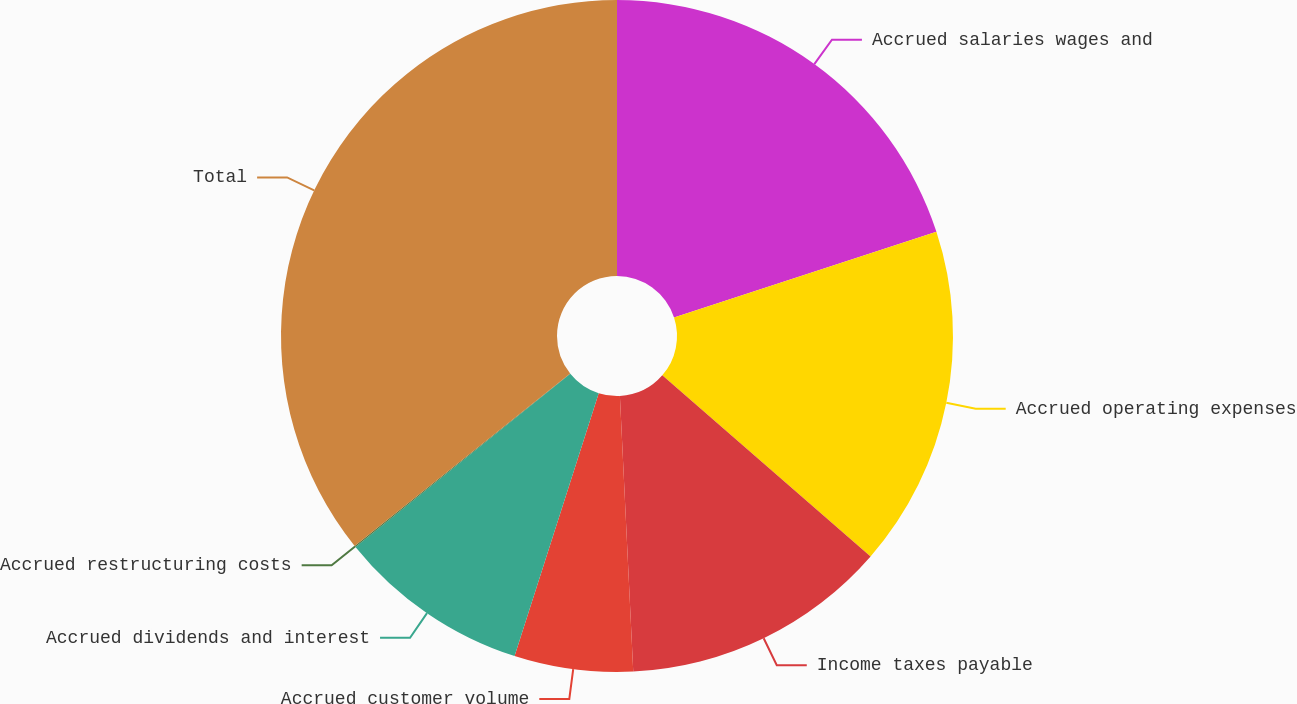Convert chart to OTSL. <chart><loc_0><loc_0><loc_500><loc_500><pie_chart><fcel>Accrued salaries wages and<fcel>Accrued operating expenses<fcel>Income taxes payable<fcel>Accrued customer volume<fcel>Accrued dividends and interest<fcel>Accrued restructuring costs<fcel>Total<nl><fcel>19.98%<fcel>16.41%<fcel>12.84%<fcel>5.7%<fcel>9.27%<fcel>0.06%<fcel>35.74%<nl></chart> 